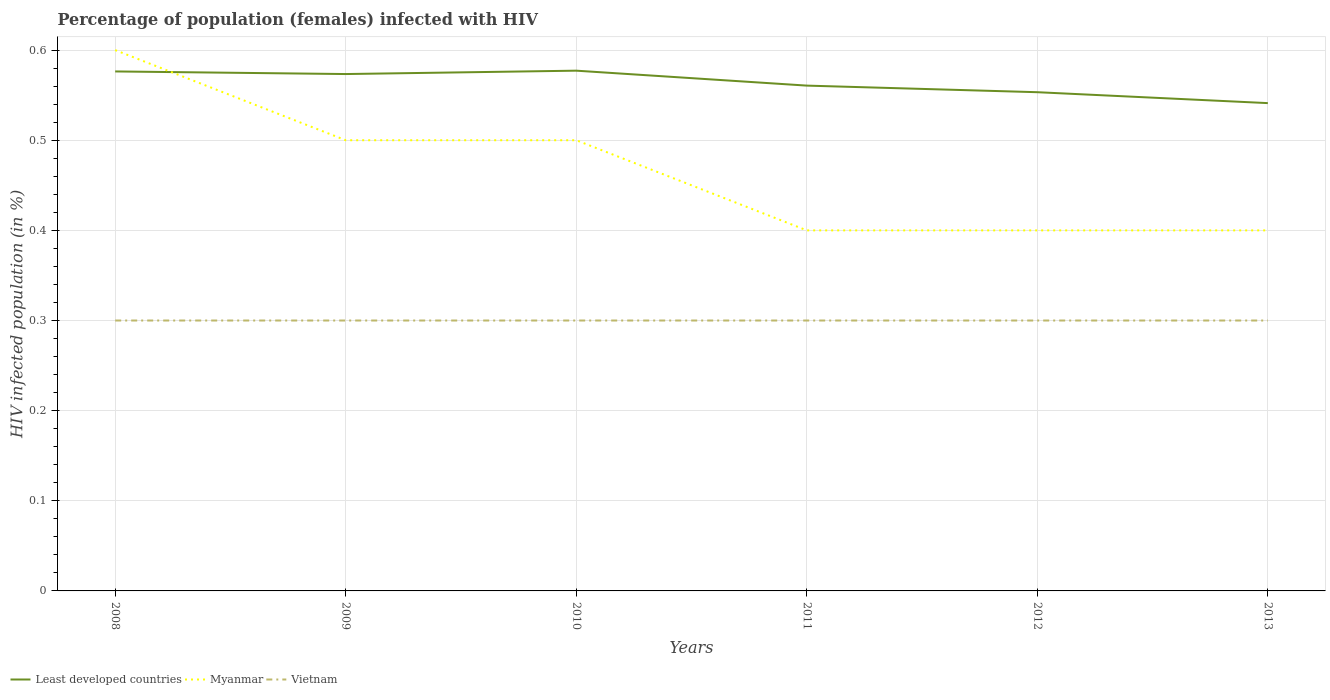Is the number of lines equal to the number of legend labels?
Your answer should be very brief. Yes. Across all years, what is the maximum percentage of HIV infected female population in Vietnam?
Provide a short and direct response. 0.3. What is the difference between the highest and the second highest percentage of HIV infected female population in Myanmar?
Ensure brevity in your answer.  0.2. How many lines are there?
Make the answer very short. 3. How many years are there in the graph?
Your response must be concise. 6. Does the graph contain any zero values?
Your response must be concise. No. Does the graph contain grids?
Keep it short and to the point. Yes. How many legend labels are there?
Your response must be concise. 3. How are the legend labels stacked?
Keep it short and to the point. Horizontal. What is the title of the graph?
Keep it short and to the point. Percentage of population (females) infected with HIV. Does "Cambodia" appear as one of the legend labels in the graph?
Make the answer very short. No. What is the label or title of the Y-axis?
Offer a terse response. HIV infected population (in %). What is the HIV infected population (in %) in Least developed countries in 2008?
Provide a succinct answer. 0.58. What is the HIV infected population (in %) of Vietnam in 2008?
Ensure brevity in your answer.  0.3. What is the HIV infected population (in %) of Least developed countries in 2009?
Keep it short and to the point. 0.57. What is the HIV infected population (in %) in Myanmar in 2009?
Your answer should be compact. 0.5. What is the HIV infected population (in %) of Least developed countries in 2010?
Provide a succinct answer. 0.58. What is the HIV infected population (in %) of Least developed countries in 2011?
Your answer should be compact. 0.56. What is the HIV infected population (in %) of Least developed countries in 2012?
Offer a terse response. 0.55. What is the HIV infected population (in %) in Vietnam in 2012?
Offer a terse response. 0.3. What is the HIV infected population (in %) in Least developed countries in 2013?
Your response must be concise. 0.54. Across all years, what is the maximum HIV infected population (in %) in Least developed countries?
Keep it short and to the point. 0.58. Across all years, what is the maximum HIV infected population (in %) in Myanmar?
Provide a short and direct response. 0.6. Across all years, what is the maximum HIV infected population (in %) of Vietnam?
Give a very brief answer. 0.3. Across all years, what is the minimum HIV infected population (in %) of Least developed countries?
Keep it short and to the point. 0.54. Across all years, what is the minimum HIV infected population (in %) in Myanmar?
Your answer should be compact. 0.4. Across all years, what is the minimum HIV infected population (in %) of Vietnam?
Ensure brevity in your answer.  0.3. What is the total HIV infected population (in %) of Least developed countries in the graph?
Provide a succinct answer. 3.38. What is the total HIV infected population (in %) of Myanmar in the graph?
Offer a very short reply. 2.8. What is the total HIV infected population (in %) of Vietnam in the graph?
Provide a short and direct response. 1.8. What is the difference between the HIV infected population (in %) in Least developed countries in 2008 and that in 2009?
Your answer should be very brief. 0. What is the difference between the HIV infected population (in %) in Myanmar in 2008 and that in 2009?
Your response must be concise. 0.1. What is the difference between the HIV infected population (in %) in Least developed countries in 2008 and that in 2010?
Provide a short and direct response. -0. What is the difference between the HIV infected population (in %) in Myanmar in 2008 and that in 2010?
Ensure brevity in your answer.  0.1. What is the difference between the HIV infected population (in %) of Least developed countries in 2008 and that in 2011?
Your response must be concise. 0.02. What is the difference between the HIV infected population (in %) of Myanmar in 2008 and that in 2011?
Provide a succinct answer. 0.2. What is the difference between the HIV infected population (in %) of Vietnam in 2008 and that in 2011?
Offer a terse response. 0. What is the difference between the HIV infected population (in %) of Least developed countries in 2008 and that in 2012?
Your answer should be very brief. 0.02. What is the difference between the HIV infected population (in %) of Vietnam in 2008 and that in 2012?
Your answer should be very brief. 0. What is the difference between the HIV infected population (in %) in Least developed countries in 2008 and that in 2013?
Provide a short and direct response. 0.04. What is the difference between the HIV infected population (in %) of Least developed countries in 2009 and that in 2010?
Your answer should be compact. -0. What is the difference between the HIV infected population (in %) in Myanmar in 2009 and that in 2010?
Provide a succinct answer. 0. What is the difference between the HIV infected population (in %) of Least developed countries in 2009 and that in 2011?
Provide a succinct answer. 0.01. What is the difference between the HIV infected population (in %) in Myanmar in 2009 and that in 2011?
Your answer should be compact. 0.1. What is the difference between the HIV infected population (in %) of Vietnam in 2009 and that in 2011?
Ensure brevity in your answer.  0. What is the difference between the HIV infected population (in %) of Least developed countries in 2009 and that in 2012?
Provide a succinct answer. 0.02. What is the difference between the HIV infected population (in %) in Vietnam in 2009 and that in 2012?
Keep it short and to the point. 0. What is the difference between the HIV infected population (in %) of Least developed countries in 2009 and that in 2013?
Your answer should be very brief. 0.03. What is the difference between the HIV infected population (in %) in Least developed countries in 2010 and that in 2011?
Provide a succinct answer. 0.02. What is the difference between the HIV infected population (in %) of Myanmar in 2010 and that in 2011?
Make the answer very short. 0.1. What is the difference between the HIV infected population (in %) of Vietnam in 2010 and that in 2011?
Provide a succinct answer. 0. What is the difference between the HIV infected population (in %) in Least developed countries in 2010 and that in 2012?
Make the answer very short. 0.02. What is the difference between the HIV infected population (in %) in Myanmar in 2010 and that in 2012?
Give a very brief answer. 0.1. What is the difference between the HIV infected population (in %) of Least developed countries in 2010 and that in 2013?
Provide a short and direct response. 0.04. What is the difference between the HIV infected population (in %) in Myanmar in 2010 and that in 2013?
Offer a terse response. 0.1. What is the difference between the HIV infected population (in %) in Least developed countries in 2011 and that in 2012?
Provide a short and direct response. 0.01. What is the difference between the HIV infected population (in %) of Vietnam in 2011 and that in 2012?
Your response must be concise. 0. What is the difference between the HIV infected population (in %) in Least developed countries in 2011 and that in 2013?
Keep it short and to the point. 0.02. What is the difference between the HIV infected population (in %) in Myanmar in 2011 and that in 2013?
Offer a very short reply. 0. What is the difference between the HIV infected population (in %) in Least developed countries in 2012 and that in 2013?
Offer a very short reply. 0.01. What is the difference between the HIV infected population (in %) of Vietnam in 2012 and that in 2013?
Your answer should be very brief. 0. What is the difference between the HIV infected population (in %) of Least developed countries in 2008 and the HIV infected population (in %) of Myanmar in 2009?
Ensure brevity in your answer.  0.08. What is the difference between the HIV infected population (in %) in Least developed countries in 2008 and the HIV infected population (in %) in Vietnam in 2009?
Provide a succinct answer. 0.28. What is the difference between the HIV infected population (in %) in Least developed countries in 2008 and the HIV infected population (in %) in Myanmar in 2010?
Your answer should be compact. 0.08. What is the difference between the HIV infected population (in %) of Least developed countries in 2008 and the HIV infected population (in %) of Vietnam in 2010?
Provide a succinct answer. 0.28. What is the difference between the HIV infected population (in %) in Myanmar in 2008 and the HIV infected population (in %) in Vietnam in 2010?
Give a very brief answer. 0.3. What is the difference between the HIV infected population (in %) of Least developed countries in 2008 and the HIV infected population (in %) of Myanmar in 2011?
Provide a succinct answer. 0.18. What is the difference between the HIV infected population (in %) of Least developed countries in 2008 and the HIV infected population (in %) of Vietnam in 2011?
Your answer should be compact. 0.28. What is the difference between the HIV infected population (in %) in Myanmar in 2008 and the HIV infected population (in %) in Vietnam in 2011?
Provide a succinct answer. 0.3. What is the difference between the HIV infected population (in %) in Least developed countries in 2008 and the HIV infected population (in %) in Myanmar in 2012?
Provide a succinct answer. 0.18. What is the difference between the HIV infected population (in %) of Least developed countries in 2008 and the HIV infected population (in %) of Vietnam in 2012?
Keep it short and to the point. 0.28. What is the difference between the HIV infected population (in %) of Least developed countries in 2008 and the HIV infected population (in %) of Myanmar in 2013?
Provide a short and direct response. 0.18. What is the difference between the HIV infected population (in %) in Least developed countries in 2008 and the HIV infected population (in %) in Vietnam in 2013?
Make the answer very short. 0.28. What is the difference between the HIV infected population (in %) of Myanmar in 2008 and the HIV infected population (in %) of Vietnam in 2013?
Provide a succinct answer. 0.3. What is the difference between the HIV infected population (in %) of Least developed countries in 2009 and the HIV infected population (in %) of Myanmar in 2010?
Your answer should be very brief. 0.07. What is the difference between the HIV infected population (in %) of Least developed countries in 2009 and the HIV infected population (in %) of Vietnam in 2010?
Offer a very short reply. 0.27. What is the difference between the HIV infected population (in %) in Least developed countries in 2009 and the HIV infected population (in %) in Myanmar in 2011?
Offer a terse response. 0.17. What is the difference between the HIV infected population (in %) of Least developed countries in 2009 and the HIV infected population (in %) of Vietnam in 2011?
Your answer should be compact. 0.27. What is the difference between the HIV infected population (in %) in Myanmar in 2009 and the HIV infected population (in %) in Vietnam in 2011?
Offer a terse response. 0.2. What is the difference between the HIV infected population (in %) of Least developed countries in 2009 and the HIV infected population (in %) of Myanmar in 2012?
Ensure brevity in your answer.  0.17. What is the difference between the HIV infected population (in %) in Least developed countries in 2009 and the HIV infected population (in %) in Vietnam in 2012?
Offer a terse response. 0.27. What is the difference between the HIV infected population (in %) in Myanmar in 2009 and the HIV infected population (in %) in Vietnam in 2012?
Ensure brevity in your answer.  0.2. What is the difference between the HIV infected population (in %) in Least developed countries in 2009 and the HIV infected population (in %) in Myanmar in 2013?
Provide a short and direct response. 0.17. What is the difference between the HIV infected population (in %) in Least developed countries in 2009 and the HIV infected population (in %) in Vietnam in 2013?
Provide a succinct answer. 0.27. What is the difference between the HIV infected population (in %) in Myanmar in 2009 and the HIV infected population (in %) in Vietnam in 2013?
Offer a very short reply. 0.2. What is the difference between the HIV infected population (in %) in Least developed countries in 2010 and the HIV infected population (in %) in Myanmar in 2011?
Offer a very short reply. 0.18. What is the difference between the HIV infected population (in %) of Least developed countries in 2010 and the HIV infected population (in %) of Vietnam in 2011?
Provide a succinct answer. 0.28. What is the difference between the HIV infected population (in %) in Least developed countries in 2010 and the HIV infected population (in %) in Myanmar in 2012?
Provide a short and direct response. 0.18. What is the difference between the HIV infected population (in %) of Least developed countries in 2010 and the HIV infected population (in %) of Vietnam in 2012?
Your answer should be compact. 0.28. What is the difference between the HIV infected population (in %) of Myanmar in 2010 and the HIV infected population (in %) of Vietnam in 2012?
Your response must be concise. 0.2. What is the difference between the HIV infected population (in %) of Least developed countries in 2010 and the HIV infected population (in %) of Myanmar in 2013?
Give a very brief answer. 0.18. What is the difference between the HIV infected population (in %) in Least developed countries in 2010 and the HIV infected population (in %) in Vietnam in 2013?
Offer a very short reply. 0.28. What is the difference between the HIV infected population (in %) of Least developed countries in 2011 and the HIV infected population (in %) of Myanmar in 2012?
Offer a terse response. 0.16. What is the difference between the HIV infected population (in %) in Least developed countries in 2011 and the HIV infected population (in %) in Vietnam in 2012?
Provide a short and direct response. 0.26. What is the difference between the HIV infected population (in %) in Myanmar in 2011 and the HIV infected population (in %) in Vietnam in 2012?
Offer a very short reply. 0.1. What is the difference between the HIV infected population (in %) in Least developed countries in 2011 and the HIV infected population (in %) in Myanmar in 2013?
Provide a short and direct response. 0.16. What is the difference between the HIV infected population (in %) of Least developed countries in 2011 and the HIV infected population (in %) of Vietnam in 2013?
Keep it short and to the point. 0.26. What is the difference between the HIV infected population (in %) of Myanmar in 2011 and the HIV infected population (in %) of Vietnam in 2013?
Offer a very short reply. 0.1. What is the difference between the HIV infected population (in %) of Least developed countries in 2012 and the HIV infected population (in %) of Myanmar in 2013?
Your answer should be very brief. 0.15. What is the difference between the HIV infected population (in %) of Least developed countries in 2012 and the HIV infected population (in %) of Vietnam in 2013?
Provide a succinct answer. 0.25. What is the difference between the HIV infected population (in %) in Myanmar in 2012 and the HIV infected population (in %) in Vietnam in 2013?
Make the answer very short. 0.1. What is the average HIV infected population (in %) of Least developed countries per year?
Make the answer very short. 0.56. What is the average HIV infected population (in %) of Myanmar per year?
Provide a succinct answer. 0.47. What is the average HIV infected population (in %) of Vietnam per year?
Keep it short and to the point. 0.3. In the year 2008, what is the difference between the HIV infected population (in %) in Least developed countries and HIV infected population (in %) in Myanmar?
Offer a terse response. -0.02. In the year 2008, what is the difference between the HIV infected population (in %) of Least developed countries and HIV infected population (in %) of Vietnam?
Ensure brevity in your answer.  0.28. In the year 2008, what is the difference between the HIV infected population (in %) of Myanmar and HIV infected population (in %) of Vietnam?
Keep it short and to the point. 0.3. In the year 2009, what is the difference between the HIV infected population (in %) in Least developed countries and HIV infected population (in %) in Myanmar?
Offer a very short reply. 0.07. In the year 2009, what is the difference between the HIV infected population (in %) of Least developed countries and HIV infected population (in %) of Vietnam?
Give a very brief answer. 0.27. In the year 2010, what is the difference between the HIV infected population (in %) in Least developed countries and HIV infected population (in %) in Myanmar?
Your response must be concise. 0.08. In the year 2010, what is the difference between the HIV infected population (in %) of Least developed countries and HIV infected population (in %) of Vietnam?
Provide a succinct answer. 0.28. In the year 2011, what is the difference between the HIV infected population (in %) of Least developed countries and HIV infected population (in %) of Myanmar?
Keep it short and to the point. 0.16. In the year 2011, what is the difference between the HIV infected population (in %) in Least developed countries and HIV infected population (in %) in Vietnam?
Give a very brief answer. 0.26. In the year 2012, what is the difference between the HIV infected population (in %) in Least developed countries and HIV infected population (in %) in Myanmar?
Keep it short and to the point. 0.15. In the year 2012, what is the difference between the HIV infected population (in %) in Least developed countries and HIV infected population (in %) in Vietnam?
Your answer should be compact. 0.25. In the year 2012, what is the difference between the HIV infected population (in %) in Myanmar and HIV infected population (in %) in Vietnam?
Ensure brevity in your answer.  0.1. In the year 2013, what is the difference between the HIV infected population (in %) in Least developed countries and HIV infected population (in %) in Myanmar?
Make the answer very short. 0.14. In the year 2013, what is the difference between the HIV infected population (in %) in Least developed countries and HIV infected population (in %) in Vietnam?
Provide a short and direct response. 0.24. In the year 2013, what is the difference between the HIV infected population (in %) in Myanmar and HIV infected population (in %) in Vietnam?
Offer a terse response. 0.1. What is the ratio of the HIV infected population (in %) of Vietnam in 2008 to that in 2010?
Your answer should be compact. 1. What is the ratio of the HIV infected population (in %) in Least developed countries in 2008 to that in 2011?
Offer a terse response. 1.03. What is the ratio of the HIV infected population (in %) of Myanmar in 2008 to that in 2011?
Your answer should be compact. 1.5. What is the ratio of the HIV infected population (in %) in Least developed countries in 2008 to that in 2012?
Your answer should be compact. 1.04. What is the ratio of the HIV infected population (in %) in Myanmar in 2008 to that in 2012?
Provide a succinct answer. 1.5. What is the ratio of the HIV infected population (in %) in Vietnam in 2008 to that in 2012?
Ensure brevity in your answer.  1. What is the ratio of the HIV infected population (in %) in Least developed countries in 2008 to that in 2013?
Your answer should be very brief. 1.06. What is the ratio of the HIV infected population (in %) in Vietnam in 2008 to that in 2013?
Your answer should be very brief. 1. What is the ratio of the HIV infected population (in %) in Vietnam in 2009 to that in 2010?
Keep it short and to the point. 1. What is the ratio of the HIV infected population (in %) in Least developed countries in 2009 to that in 2011?
Offer a very short reply. 1.02. What is the ratio of the HIV infected population (in %) of Myanmar in 2009 to that in 2011?
Provide a short and direct response. 1.25. What is the ratio of the HIV infected population (in %) of Vietnam in 2009 to that in 2011?
Offer a terse response. 1. What is the ratio of the HIV infected population (in %) of Least developed countries in 2009 to that in 2012?
Provide a succinct answer. 1.04. What is the ratio of the HIV infected population (in %) in Least developed countries in 2009 to that in 2013?
Your response must be concise. 1.06. What is the ratio of the HIV infected population (in %) in Least developed countries in 2010 to that in 2011?
Your response must be concise. 1.03. What is the ratio of the HIV infected population (in %) of Vietnam in 2010 to that in 2011?
Your answer should be very brief. 1. What is the ratio of the HIV infected population (in %) of Least developed countries in 2010 to that in 2012?
Your answer should be compact. 1.04. What is the ratio of the HIV infected population (in %) in Least developed countries in 2010 to that in 2013?
Keep it short and to the point. 1.07. What is the ratio of the HIV infected population (in %) in Least developed countries in 2011 to that in 2012?
Ensure brevity in your answer.  1.01. What is the ratio of the HIV infected population (in %) in Least developed countries in 2011 to that in 2013?
Make the answer very short. 1.04. What is the ratio of the HIV infected population (in %) of Vietnam in 2011 to that in 2013?
Give a very brief answer. 1. What is the ratio of the HIV infected population (in %) in Least developed countries in 2012 to that in 2013?
Offer a very short reply. 1.02. What is the ratio of the HIV infected population (in %) in Vietnam in 2012 to that in 2013?
Give a very brief answer. 1. What is the difference between the highest and the second highest HIV infected population (in %) of Least developed countries?
Your answer should be compact. 0. What is the difference between the highest and the lowest HIV infected population (in %) in Least developed countries?
Offer a terse response. 0.04. What is the difference between the highest and the lowest HIV infected population (in %) in Vietnam?
Provide a succinct answer. 0. 